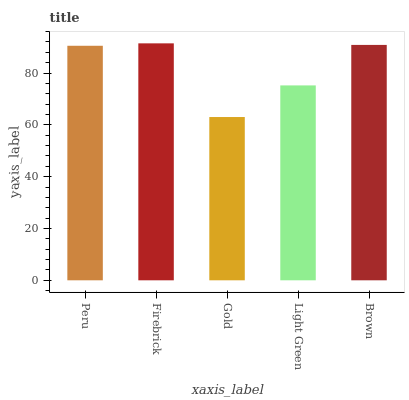Is Gold the minimum?
Answer yes or no. Yes. Is Firebrick the maximum?
Answer yes or no. Yes. Is Firebrick the minimum?
Answer yes or no. No. Is Gold the maximum?
Answer yes or no. No. Is Firebrick greater than Gold?
Answer yes or no. Yes. Is Gold less than Firebrick?
Answer yes or no. Yes. Is Gold greater than Firebrick?
Answer yes or no. No. Is Firebrick less than Gold?
Answer yes or no. No. Is Peru the high median?
Answer yes or no. Yes. Is Peru the low median?
Answer yes or no. Yes. Is Light Green the high median?
Answer yes or no. No. Is Gold the low median?
Answer yes or no. No. 